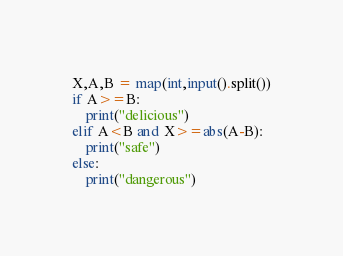<code> <loc_0><loc_0><loc_500><loc_500><_Python_>X,A,B = map(int,input().split())
if A>=B:
    print("delicious")
elif A<B and X>=abs(A-B):
    print("safe")
else:
    print("dangerous")</code> 